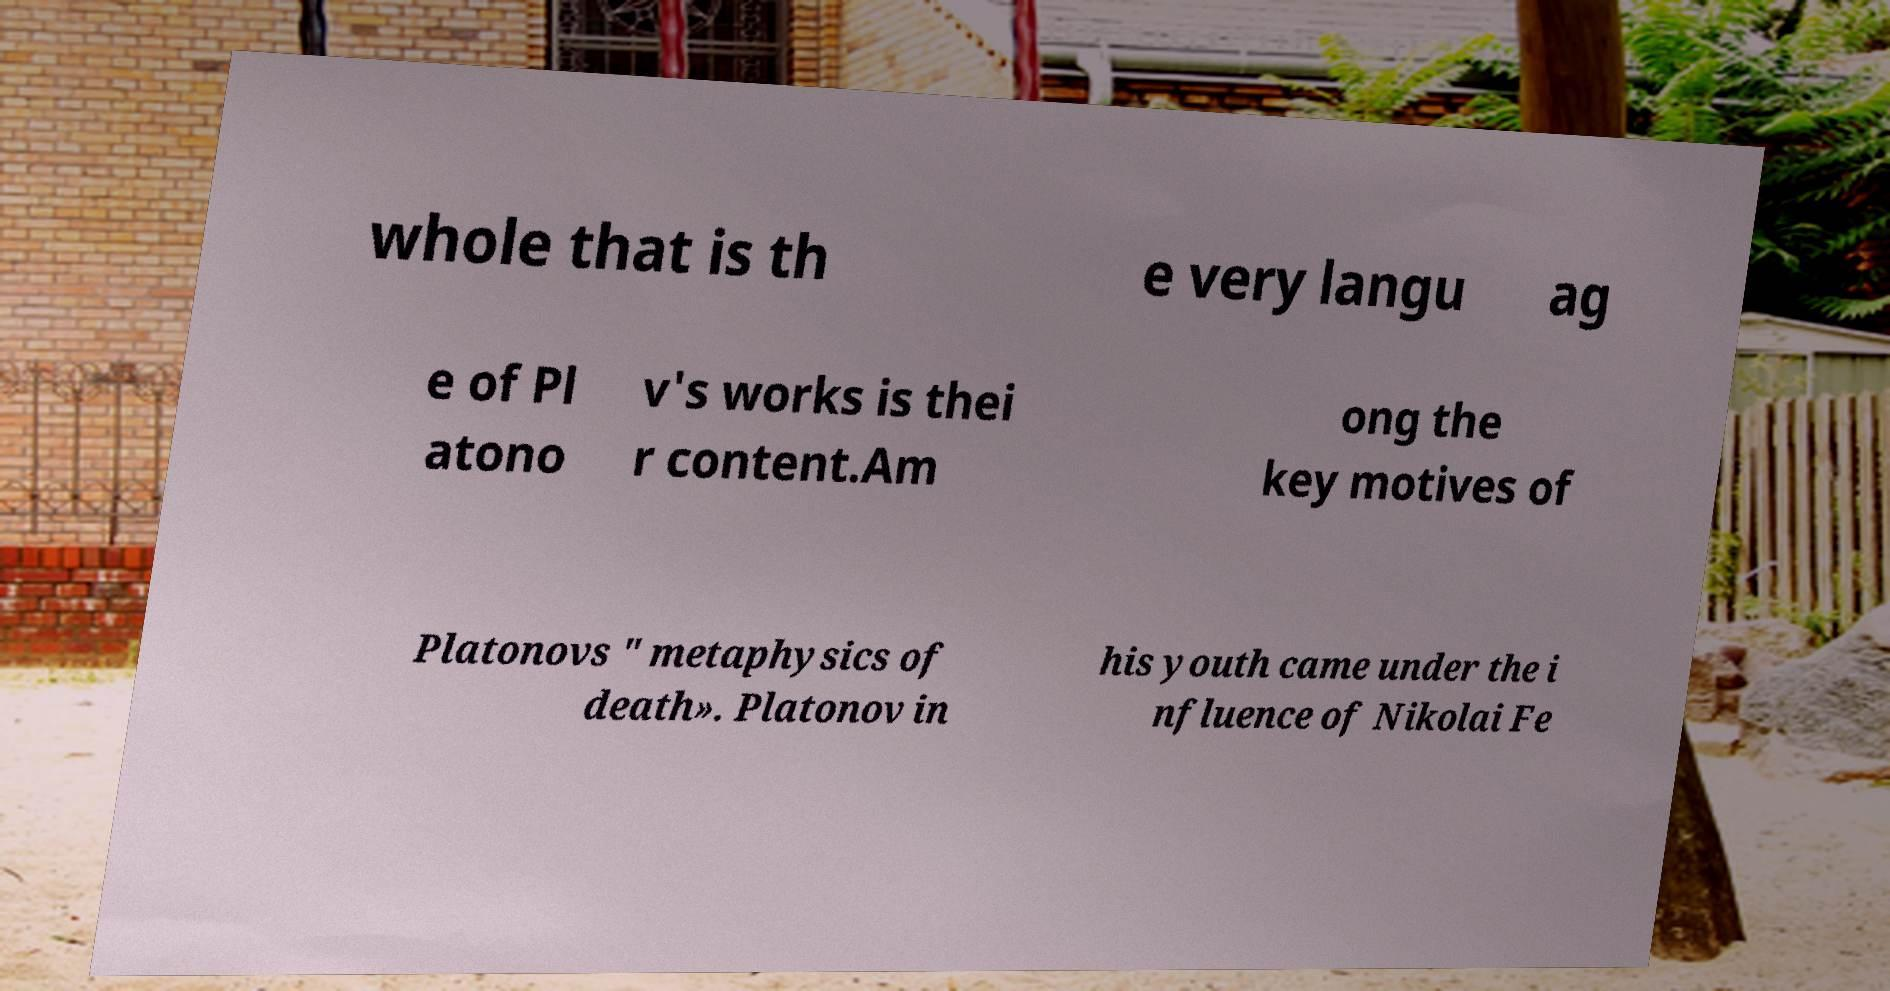Please read and relay the text visible in this image. What does it say? whole that is th e very langu ag e of Pl atono v's works is thei r content.Am ong the key motives of Platonovs " metaphysics of death». Platonov in his youth came under the i nfluence of Nikolai Fe 